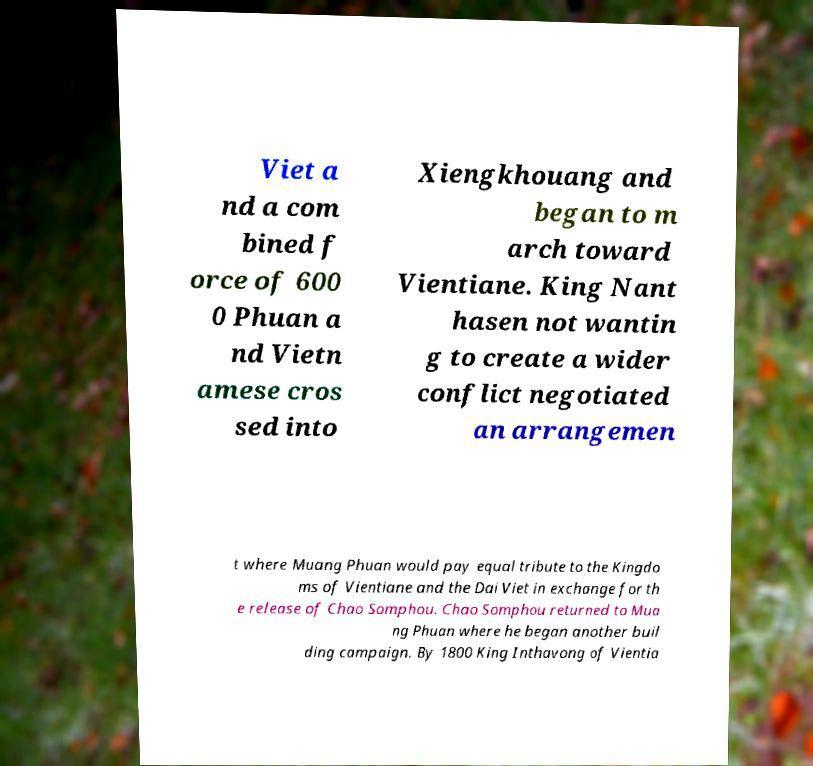For documentation purposes, I need the text within this image transcribed. Could you provide that? Viet a nd a com bined f orce of 600 0 Phuan a nd Vietn amese cros sed into Xiengkhouang and began to m arch toward Vientiane. King Nant hasen not wantin g to create a wider conflict negotiated an arrangemen t where Muang Phuan would pay equal tribute to the Kingdo ms of Vientiane and the Dai Viet in exchange for th e release of Chao Somphou. Chao Somphou returned to Mua ng Phuan where he began another buil ding campaign. By 1800 King Inthavong of Vientia 